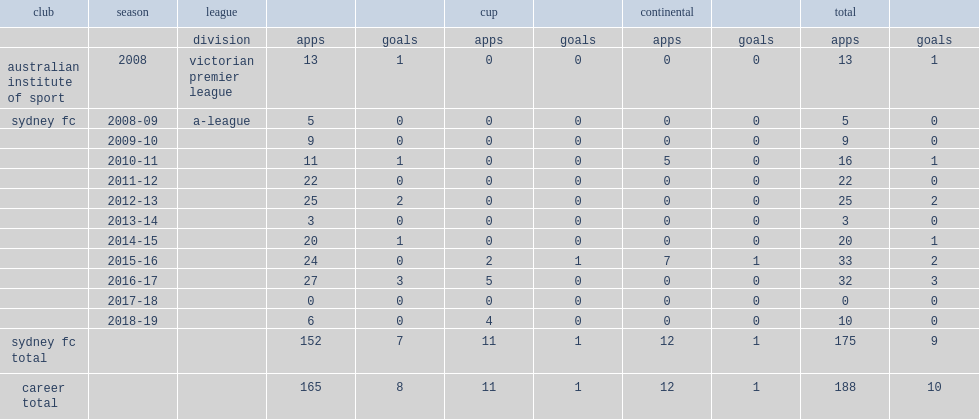Which club did grant play for in 2010-11? Sydney fc. Parse the table in full. {'header': ['club', 'season', 'league', '', '', 'cup', '', 'continental', '', 'total', ''], 'rows': [['', '', 'division', 'apps', 'goals', 'apps', 'goals', 'apps', 'goals', 'apps', 'goals'], ['australian institute of sport', '2008', 'victorian premier league', '13', '1', '0', '0', '0', '0', '13', '1'], ['sydney fc', '2008-09', 'a-league', '5', '0', '0', '0', '0', '0', '5', '0'], ['', '2009-10', '', '9', '0', '0', '0', '0', '0', '9', '0'], ['', '2010-11', '', '11', '1', '0', '0', '5', '0', '16', '1'], ['', '2011-12', '', '22', '0', '0', '0', '0', '0', '22', '0'], ['', '2012-13', '', '25', '2', '0', '0', '0', '0', '25', '2'], ['', '2013-14', '', '3', '0', '0', '0', '0', '0', '3', '0'], ['', '2014-15', '', '20', '1', '0', '0', '0', '0', '20', '1'], ['', '2015-16', '', '24', '0', '2', '1', '7', '1', '33', '2'], ['', '2016-17', '', '27', '3', '5', '0', '0', '0', '32', '3'], ['', '2017-18', '', '0', '0', '0', '0', '0', '0', '0', '0'], ['', '2018-19', '', '6', '0', '4', '0', '0', '0', '10', '0'], ['sydney fc total', '', '', '152', '7', '11', '1', '12', '1', '175', '9'], ['career total', '', '', '165', '8', '11', '1', '12', '1', '188', '10']]} 